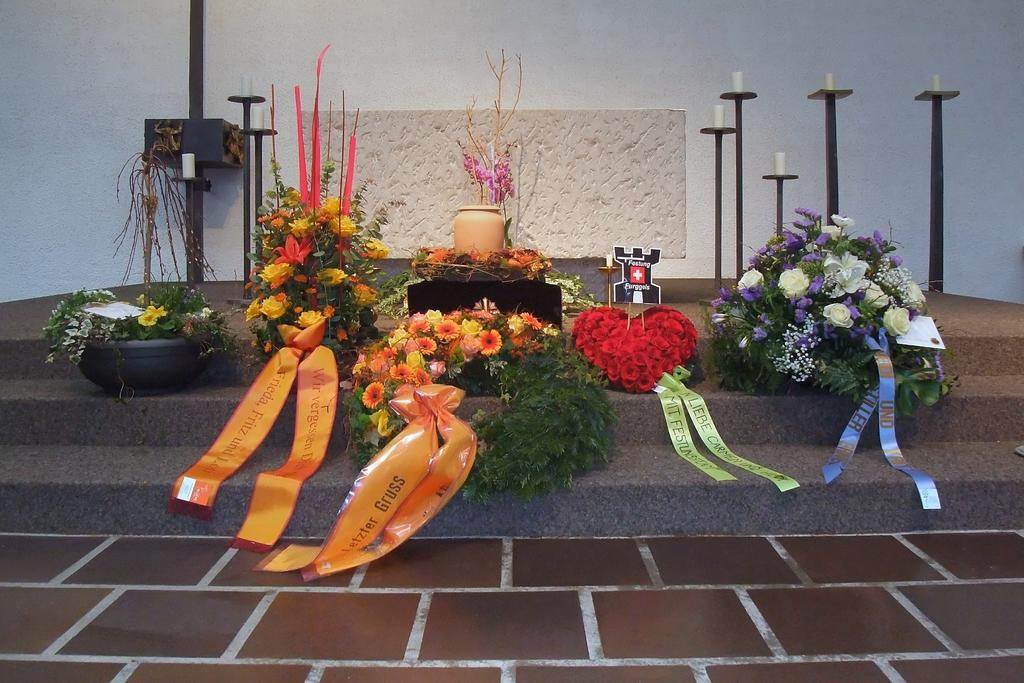What type of decorative items can be seen in the image? There are flower bouquets and candles with stands in the image. Can you describe the candles in the image? The candles in the image are accompanied by stands. What type of lamp is present in the image? There is no lamp present in the image. What is the reason for the flower bouquets and candles being placed together in the image? The image does not provide any information about the reason for the arrangement of the flower bouquets and candles. 